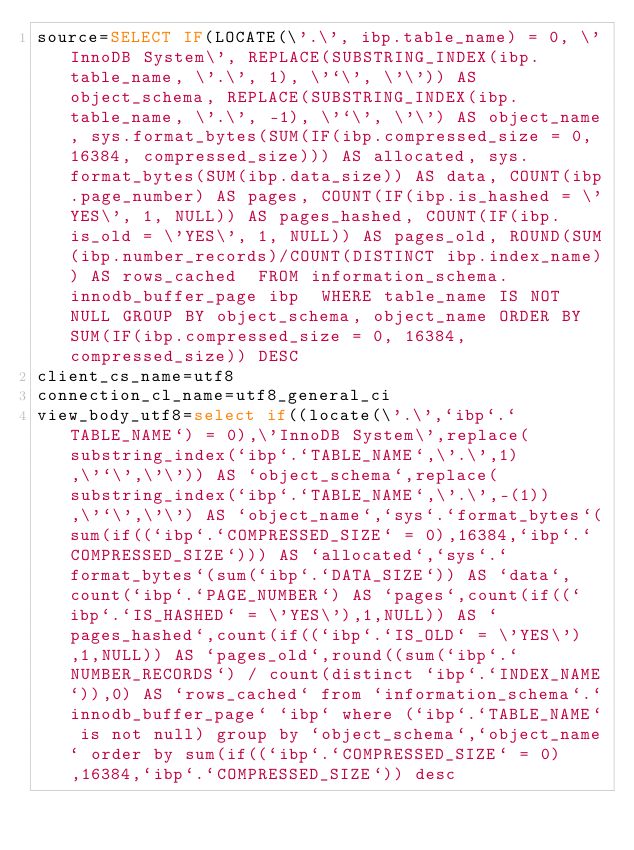<code> <loc_0><loc_0><loc_500><loc_500><_VisualBasic_>source=SELECT IF(LOCATE(\'.\', ibp.table_name) = 0, \'InnoDB System\', REPLACE(SUBSTRING_INDEX(ibp.table_name, \'.\', 1), \'`\', \'\')) AS object_schema, REPLACE(SUBSTRING_INDEX(ibp.table_name, \'.\', -1), \'`\', \'\') AS object_name, sys.format_bytes(SUM(IF(ibp.compressed_size = 0, 16384, compressed_size))) AS allocated, sys.format_bytes(SUM(ibp.data_size)) AS data, COUNT(ibp.page_number) AS pages, COUNT(IF(ibp.is_hashed = \'YES\', 1, NULL)) AS pages_hashed, COUNT(IF(ibp.is_old = \'YES\', 1, NULL)) AS pages_old, ROUND(SUM(ibp.number_records)/COUNT(DISTINCT ibp.index_name)) AS rows_cached  FROM information_schema.innodb_buffer_page ibp  WHERE table_name IS NOT NULL GROUP BY object_schema, object_name ORDER BY SUM(IF(ibp.compressed_size = 0, 16384, compressed_size)) DESC
client_cs_name=utf8
connection_cl_name=utf8_general_ci
view_body_utf8=select if((locate(\'.\',`ibp`.`TABLE_NAME`) = 0),\'InnoDB System\',replace(substring_index(`ibp`.`TABLE_NAME`,\'.\',1),\'`\',\'\')) AS `object_schema`,replace(substring_index(`ibp`.`TABLE_NAME`,\'.\',-(1)),\'`\',\'\') AS `object_name`,`sys`.`format_bytes`(sum(if((`ibp`.`COMPRESSED_SIZE` = 0),16384,`ibp`.`COMPRESSED_SIZE`))) AS `allocated`,`sys`.`format_bytes`(sum(`ibp`.`DATA_SIZE`)) AS `data`,count(`ibp`.`PAGE_NUMBER`) AS `pages`,count(if((`ibp`.`IS_HASHED` = \'YES\'),1,NULL)) AS `pages_hashed`,count(if((`ibp`.`IS_OLD` = \'YES\'),1,NULL)) AS `pages_old`,round((sum(`ibp`.`NUMBER_RECORDS`) / count(distinct `ibp`.`INDEX_NAME`)),0) AS `rows_cached` from `information_schema`.`innodb_buffer_page` `ibp` where (`ibp`.`TABLE_NAME` is not null) group by `object_schema`,`object_name` order by sum(if((`ibp`.`COMPRESSED_SIZE` = 0),16384,`ibp`.`COMPRESSED_SIZE`)) desc
</code> 